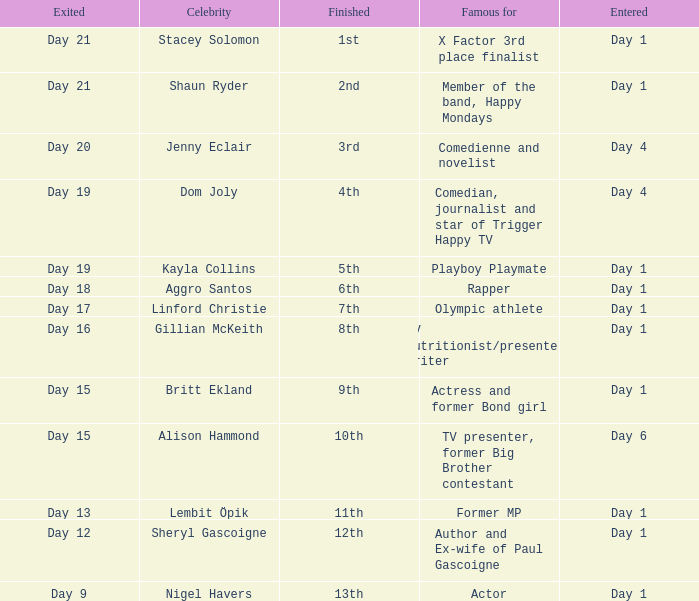What position did the celebrity finish that entered on day 1 and exited on day 15? 9th. 